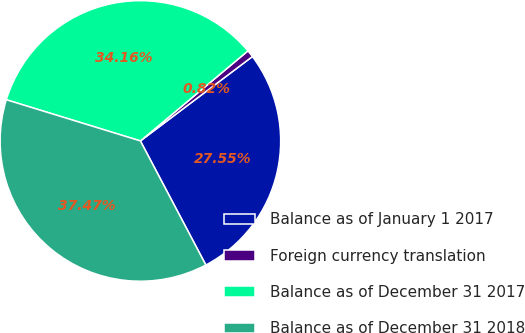Convert chart. <chart><loc_0><loc_0><loc_500><loc_500><pie_chart><fcel>Balance as of January 1 2017<fcel>Foreign currency translation<fcel>Balance as of December 31 2017<fcel>Balance as of December 31 2018<nl><fcel>27.55%<fcel>0.82%<fcel>34.16%<fcel>37.47%<nl></chart> 